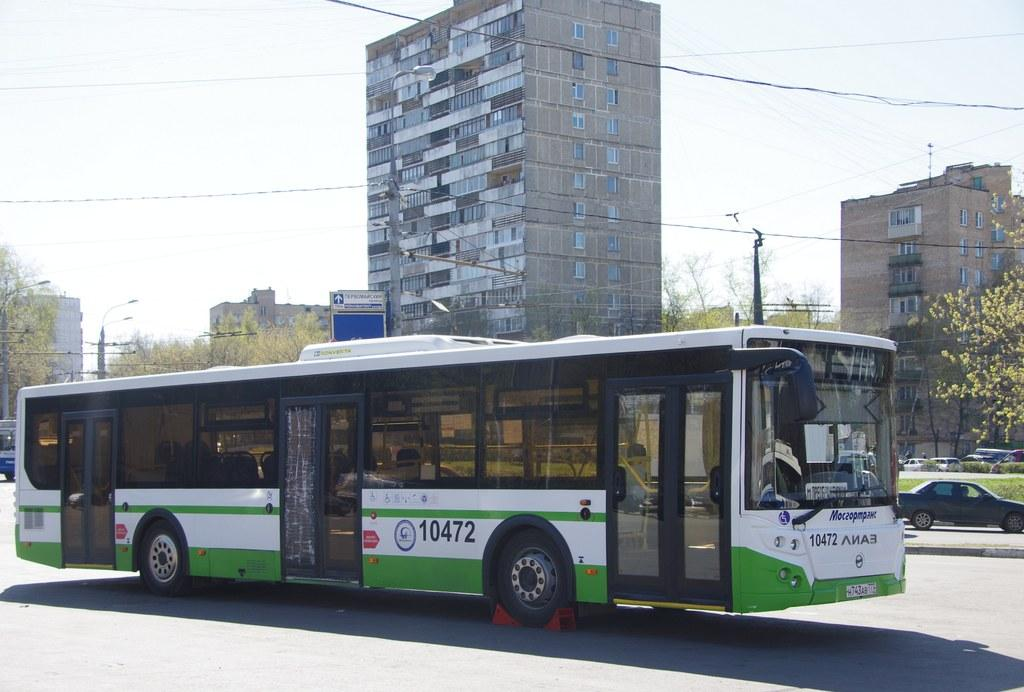<image>
Summarize the visual content of the image. The green and white bus has the number 10472 on it 